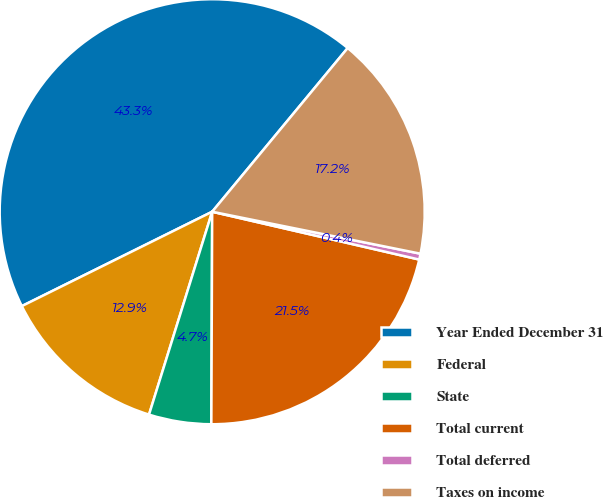Convert chart to OTSL. <chart><loc_0><loc_0><loc_500><loc_500><pie_chart><fcel>Year Ended December 31<fcel>Federal<fcel>State<fcel>Total current<fcel>Total deferred<fcel>Taxes on income<nl><fcel>43.33%<fcel>12.87%<fcel>4.74%<fcel>21.45%<fcel>0.45%<fcel>17.16%<nl></chart> 